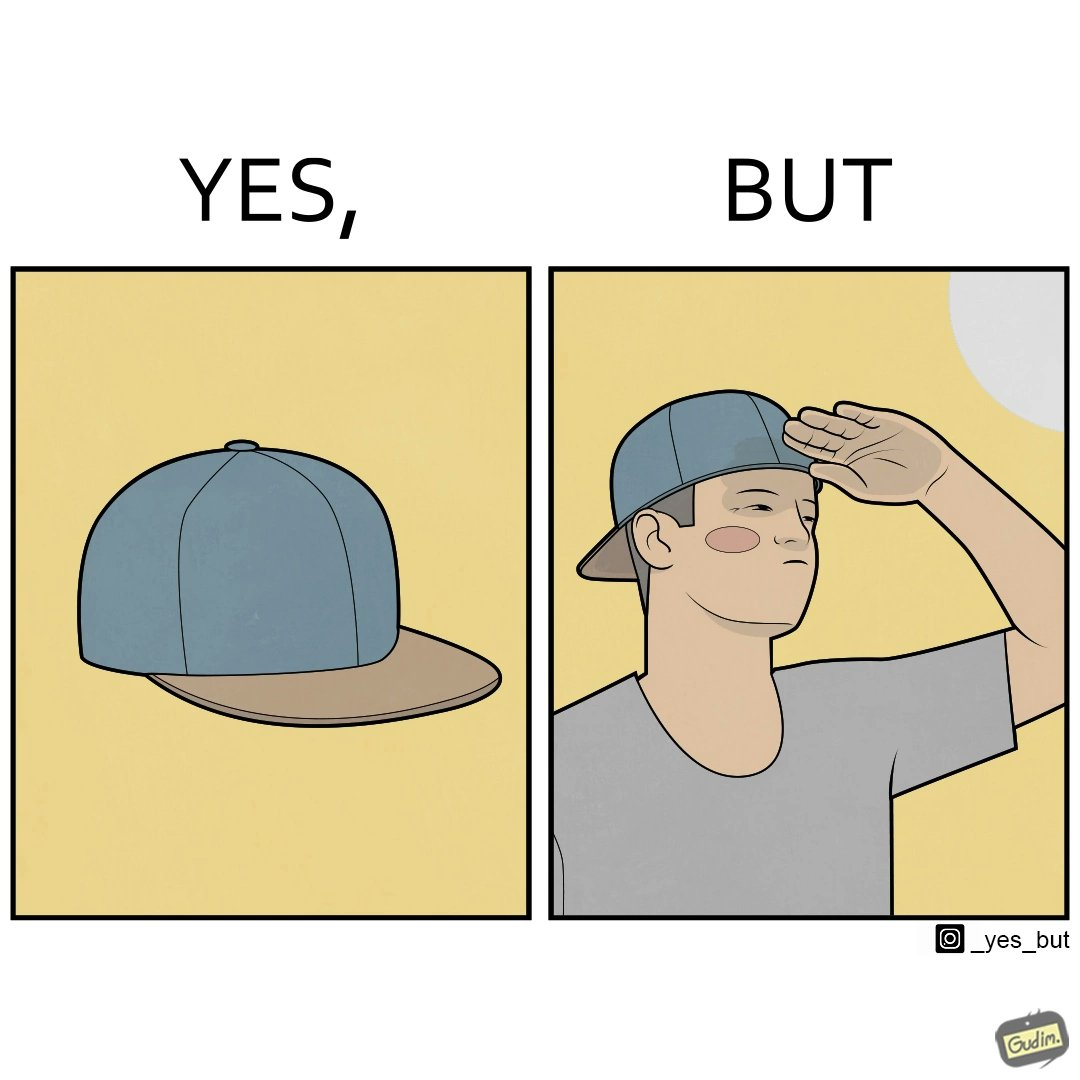What is the satirical meaning behind this image? This image is funny because a cap is MEANT to protect one's eyes from the sun, but this person is more interested in using it to look stylish, even if it makes them uncomfortable. 